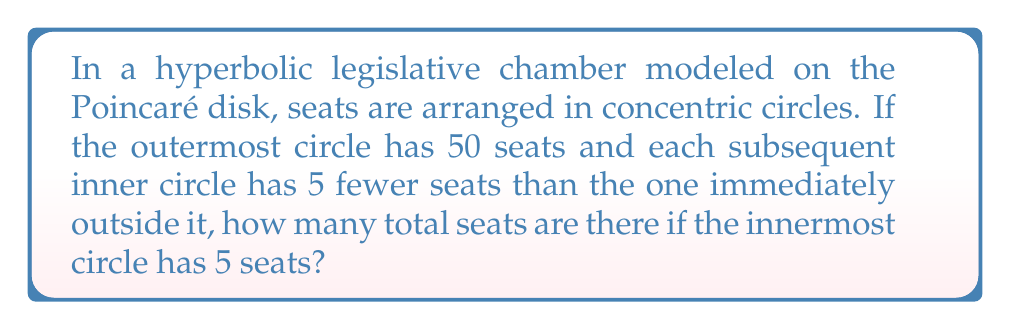Give your solution to this math problem. Let's approach this step-by-step:

1) First, we need to determine how many circles of seats there are. We know:
   - The outermost circle has 50 seats
   - Each subsequent circle has 5 fewer seats
   - The innermost circle has 5 seats

2) Let's list out the number of seats in each circle, starting from the outermost:
   50, 45, 40, 35, 30, 25, 20, 15, 10, 5

3) We can see that there are 10 circles in total.

4) Now, we need to sum up all these seats. We could add them individually, but there's a more efficient way using the arithmetic sequence formula:

   $$S_n = \frac{n}{2}(a_1 + a_n)$$

   Where:
   $S_n$ is the sum of the sequence
   $n$ is the number of terms
   $a_1$ is the first term
   $a_n$ is the last term

5) In our case:
   $n = 10$ (number of circles)
   $a_1 = 50$ (seats in the outermost circle)
   $a_n = 5$ (seats in the innermost circle)

6) Plugging these into the formula:

   $$S_{10} = \frac{10}{2}(50 + 5) = 5(55) = 275$$

Therefore, the total number of seats in the hyperbolic legislative chamber is 275.
Answer: 275 seats 